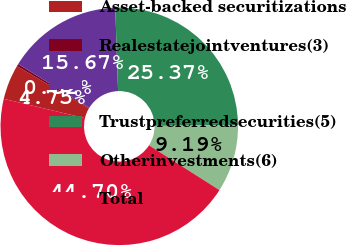<chart> <loc_0><loc_0><loc_500><loc_500><pie_chart><fcel>Asset-backed securitizations<fcel>Realestatejointventures(3)<fcel>Unnamed: 2<fcel>Trustpreferredsecurities(5)<fcel>Otherinvestments(6)<fcel>Total<nl><fcel>4.75%<fcel>0.32%<fcel>15.67%<fcel>25.37%<fcel>9.19%<fcel>44.7%<nl></chart> 